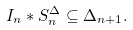Convert formula to latex. <formula><loc_0><loc_0><loc_500><loc_500>I _ { n } * S _ { n } ^ { \Delta } \subseteq \Delta _ { n + 1 } .</formula> 